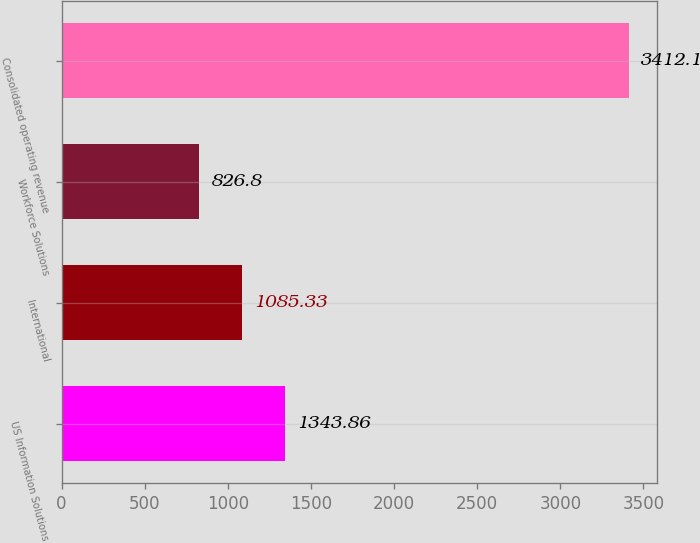Convert chart. <chart><loc_0><loc_0><loc_500><loc_500><bar_chart><fcel>US Information Solutions<fcel>International<fcel>Workforce Solutions<fcel>Consolidated operating revenue<nl><fcel>1343.86<fcel>1085.33<fcel>826.8<fcel>3412.1<nl></chart> 